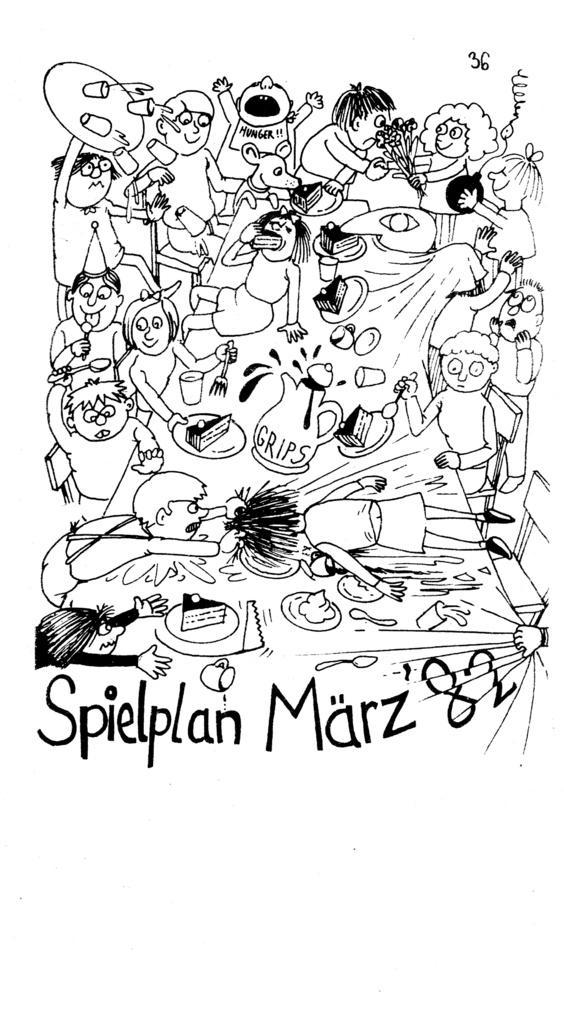Could you give a brief overview of what you see in this image? We can see poster,on this poster we can see people and text. 